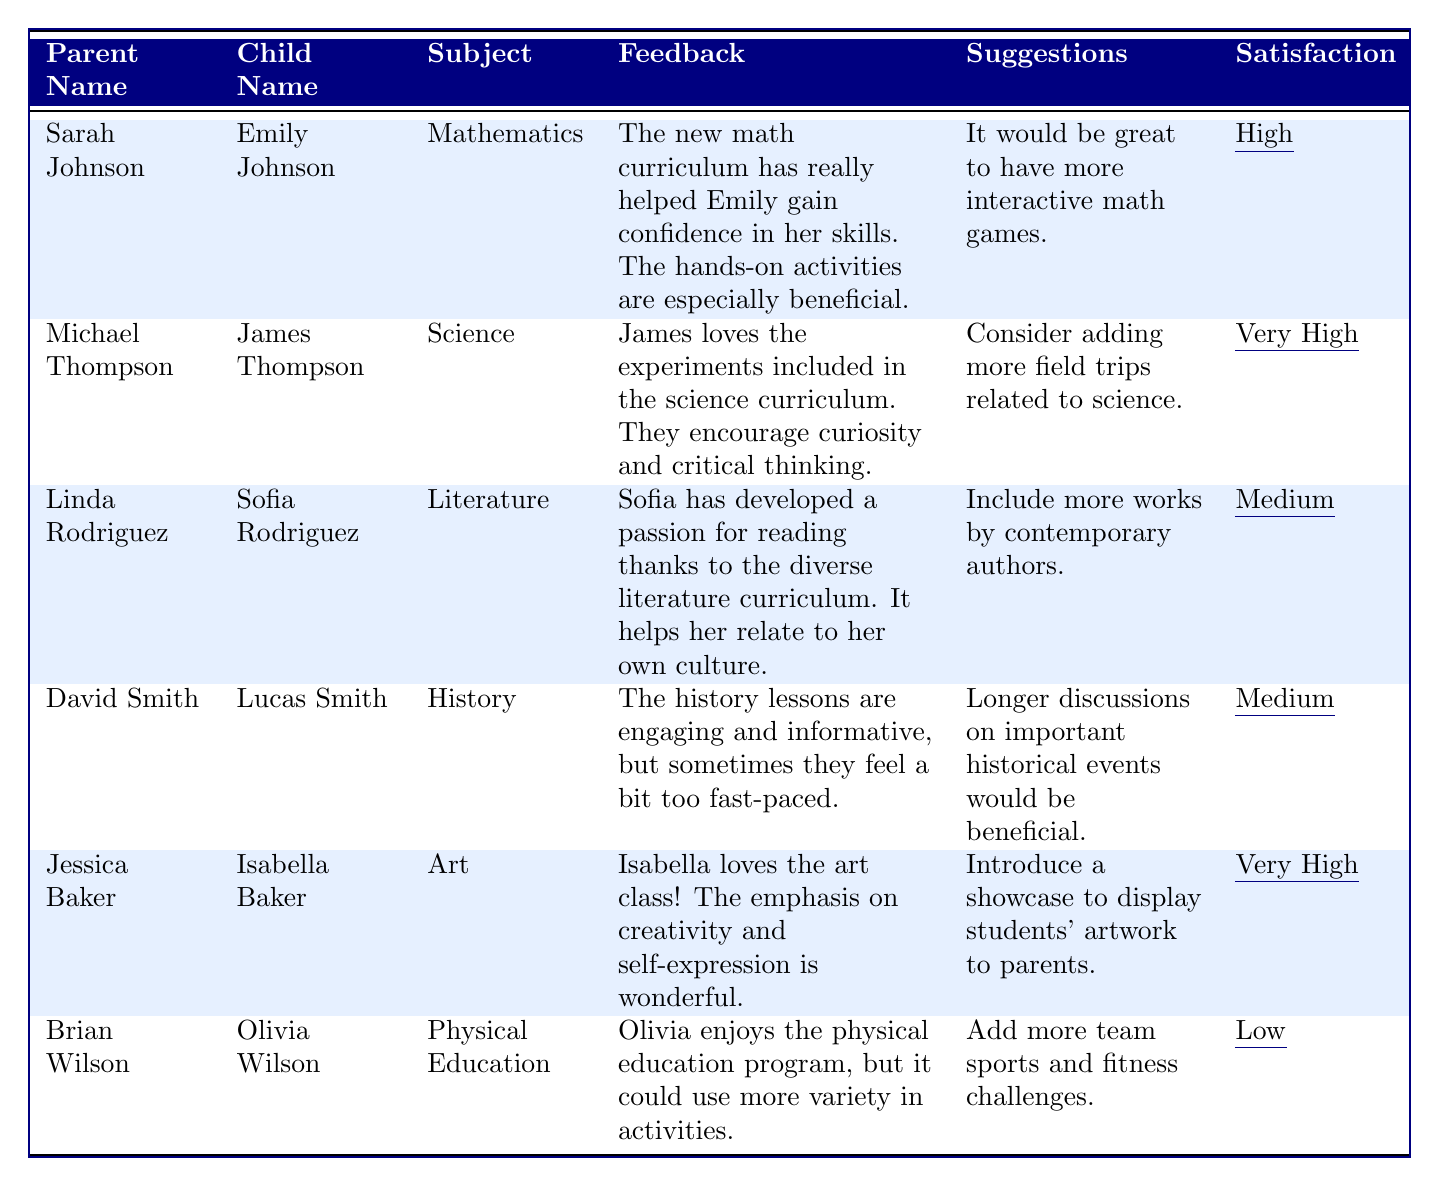What is the satisfaction level of Michael Thompson regarding the science curriculum? The table indicates that Michael Thompson's satisfaction level is noted beside his feedback for the science curriculum. It states "Very High".
Answer: Very High What suggestion did Sarah Johnson provide for the mathematics curriculum? Looking at the suggestions column, Sarah Johnson suggested having more interactive math games for the mathematics curriculum.
Answer: More interactive math games How many parents have a satisfaction level categorized as "Medium"? The table lists three parents with a satisfaction level of "Medium": Linda Rodriguez, David Smith, and their respective subjects. Counting these gives us three parents.
Answer: 2 True or False: Jessica Baker suggested introducing a showcase to display students' artwork to parents. By referencing the suggestions column for Jessica Baker, it is confirmed that she indeed suggested introducing a showcase for students' artwork.
Answer: True Which subject received the highest satisfaction level from parents? Evaluating the satisfaction levels, "Very High" was given for the science and art subjects both. We summarize that each respective parent has provided feedback that indicates a high satisfaction for those subjects.
Answer: Science and Art What feedback did David Smith provide about the history curriculum? David Smith's feedback mentions that the history lessons are engaging and informative, but they sometimes feel a bit too fast-paced. This can be referenced in the feedback column.
Answer: History lessons are engaging but sometimes too fast-paced Which subject received the lowest satisfaction level, and what was the concern related to it? The table indicates that the lowest satisfaction level is "Low" for the Physical Education subject. The concern was that it could use more variety in activities, as stated by Brian Wilson.
Answer: Physical Education; could use more variety in activities How many parents suggested adding more field trips related to their subjects? The feedback for science mentions a suggestion to consider adding more field trips. This demonstrates that there is one parent who suggested this concern.
Answer: 1 List the names of the children whose parents expressed "Very High" satisfaction. By examining the table, the children associated with "Very High" satisfaction from their parents are James Thompson and Isabella Baker.
Answer: James Thompson, Isabella Baker What common theme can be identified in the suggestions provided by parents regarding curriculum improvements? The suggestions span either adding more interaction (games in math) or ensuring inclusion of diverse experiences (field trips in science). This indicates that parents desire more experiential and engaging elements in the curriculum.
Answer: Desire for more interactive and engaging experiences 